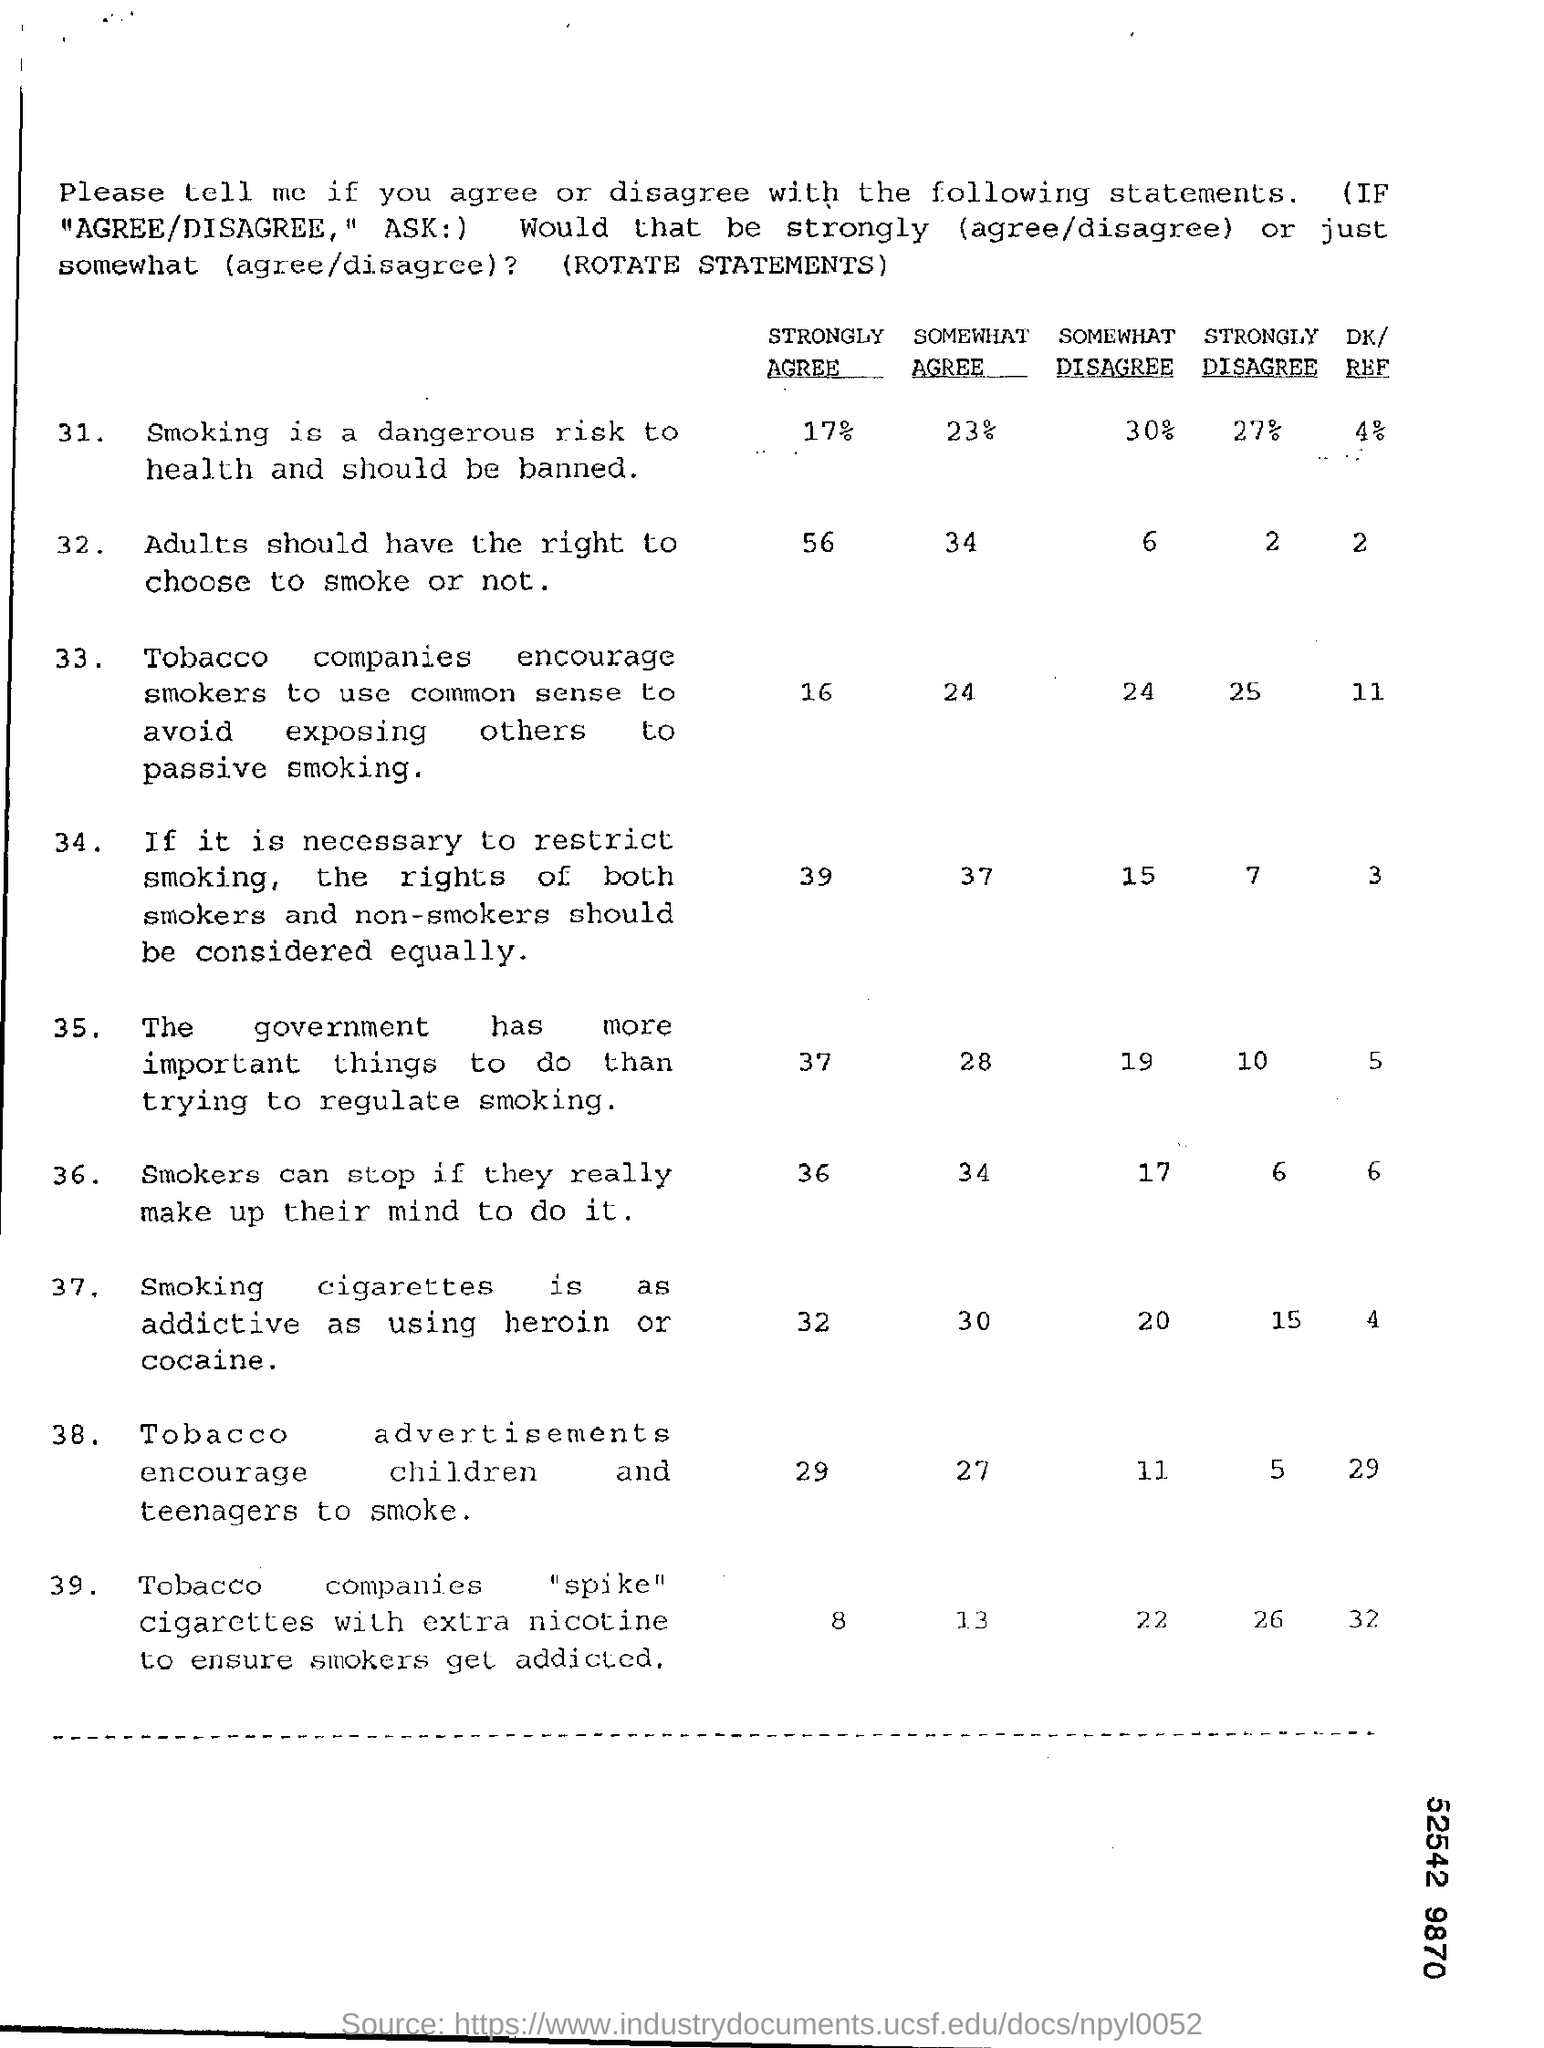What percentage of people strongly agree that smoking is a dangerous risk to health and should be banned?
Make the answer very short. 17%. What percentage of people somewhat agree that smoking is a dangerous risk to health and should be banned?
Offer a terse response. 23. What percentage of people somewhat disagree that smoking is a dangerous risk to health and should be banned?
Your answer should be compact. 30%. What percentage of people strongly disagree that smoking is a dangerous risk to health and should be banned?
Ensure brevity in your answer.  27. What percentage of people say DK/REF that smoking is a dangerous risk to health and should be banned?
Your response must be concise. 4. What percentage of people strongly agree that Adults should have the right to choose to smoke or not?
Your answer should be compact. 56. What percentage of people somewhat agree that Adults should have the right to choose to smoke or not?
Your answer should be compact. 34. What percentage of people somewhat disagree that Adults should have the right to choose to smoke or not?
Keep it short and to the point. 6. What percentage of people strongly disagree that Adults should have the right to choose to smoke or not?
Ensure brevity in your answer.  2. What percentage of people say DK/REF that Adults should have the right to choose to smoke or not?
Ensure brevity in your answer.  2. 